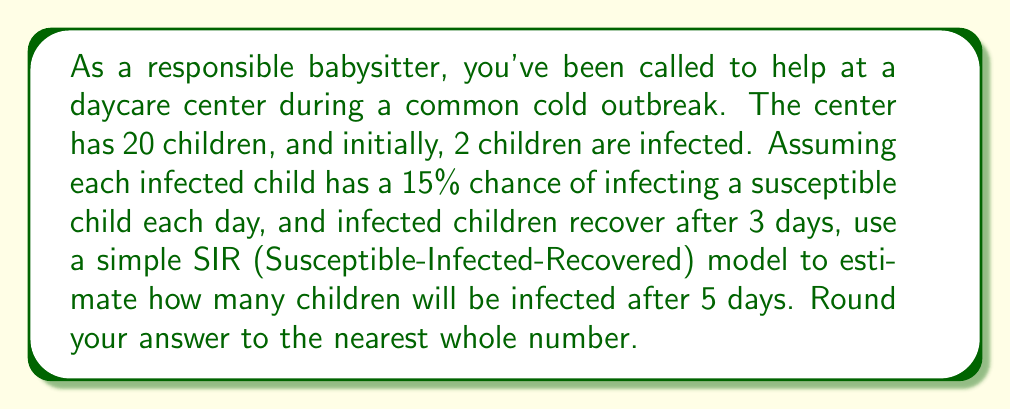Could you help me with this problem? Let's use a discrete-time SIR model to simulate the spread of the common cold:

1) Define variables:
   $S_t$ = Susceptible children on day $t$
   $I_t$ = Infected children on day $t$
   $R_t$ = Recovered children on day $t$

2) Initial conditions:
   $S_0 = 18$, $I_0 = 2$, $R_0 = 0$

3) Model parameters:
   $\beta = 0.15$ (infection rate)
   $\gamma = \frac{1}{3}$ (recovery rate)

4) SIR model equations:
   $$S_{t+1} = S_t - \beta S_t I_t / N$$
   $$I_{t+1} = I_t + \beta S_t I_t / N - \gamma I_t$$
   $$R_{t+1} = R_t + \gamma I_t$$

   Where $N = 20$ (total population)

5) Calculate for each day:

   Day 1:
   $S_1 = 18 - 0.15 * 18 * 2 / 20 = 16.73$
   $I_1 = 2 + 0.15 * 18 * 2 / 20 - (1/3) * 2 = 2.60$
   $R_1 = 0 + (1/3) * 2 = 0.67$

   Day 2:
   $S_2 = 16.73 - 0.15 * 16.73 * 2.60 / 20 = 15.19$
   $I_2 = 2.60 + 0.15 * 16.73 * 2.60 / 20 - (1/3) * 2.60 = 3.27$
   $R_2 = 0.67 + (1/3) * 2.60 = 1.54$

   Day 3:
   $S_3 = 15.19 - 0.15 * 15.19 * 3.27 / 20 = 13.44$
   $I_3 = 3.27 + 0.15 * 15.19 * 3.27 / 20 - (1/3) * 3.27 = 3.94$
   $R_3 = 1.54 + (1/3) * 3.27 = 2.62$

   Day 4:
   $S_4 = 13.44 - 0.15 * 13.44 * 3.94 / 20 = 11.55$
   $I_4 = 3.94 + 0.15 * 13.44 * 3.94 / 20 - (1/3) * 3.94 = 4.56$
   $R_4 = 2.62 + (1/3) * 3.94 = 3.89$

   Day 5:
   $S_5 = 11.55 - 0.15 * 11.55 * 4.56 / 20 = 9.66$
   $I_5 = 4.56 + 0.15 * 11.55 * 4.56 / 20 - (1/3) * 4.56 = 5.07$
   $R_5 = 3.89 + (1/3) * 4.56 = 5.27$

6) The number of infected children after 5 days is $I_5 = 5.07$

7) Rounding to the nearest whole number: 5
Answer: 5 children 